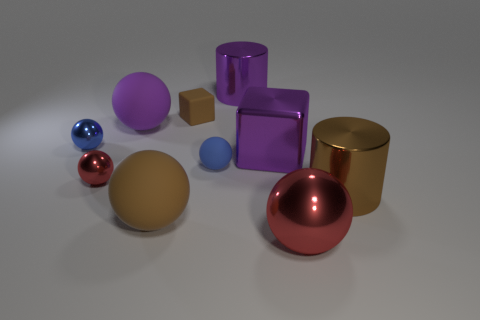Subtract all tiny red spheres. How many spheres are left? 5 Subtract all purple spheres. How many spheres are left? 5 Subtract all yellow cylinders. Subtract all brown blocks. How many cylinders are left? 2 Subtract all green cubes. How many cyan cylinders are left? 0 Subtract all yellow rubber balls. Subtract all big red shiny balls. How many objects are left? 9 Add 8 rubber cubes. How many rubber cubes are left? 9 Add 6 large green things. How many large green things exist? 6 Subtract 0 yellow balls. How many objects are left? 10 Subtract all spheres. How many objects are left? 4 Subtract 1 cylinders. How many cylinders are left? 1 